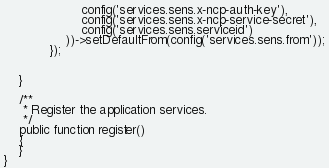Convert code to text. <code><loc_0><loc_0><loc_500><loc_500><_PHP_>                    config('services.sens.x-ncp-auth-key'),
                    config('services.sens.x-ncp-service-secret'),
                    config('services.sens.serviceid')
                ))->setDefaultFrom(config('services.sens.from'));
            });


    }

    /**
     * Register the application services.
     */
    public function register()
    {
    }
}
</code> 